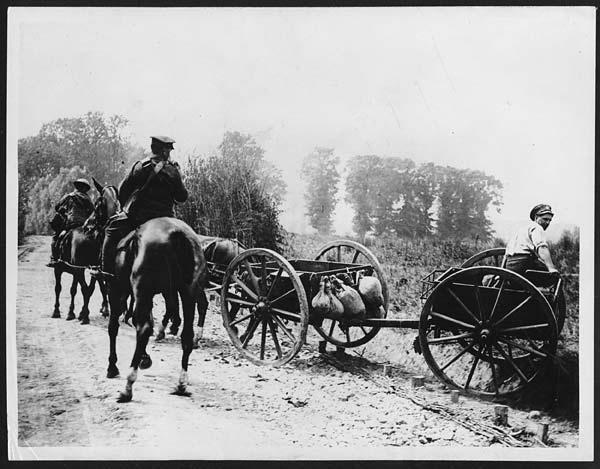How many people are in the picture?
Give a very brief answer. 2. How many horses can be seen?
Give a very brief answer. 3. 